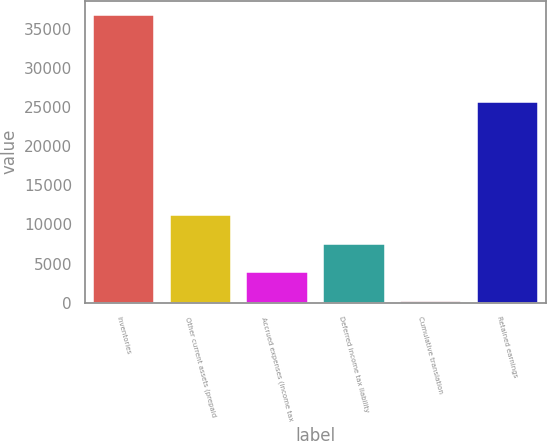Convert chart to OTSL. <chart><loc_0><loc_0><loc_500><loc_500><bar_chart><fcel>Inventories<fcel>Other current assets (prepaid<fcel>Accrued expenses (income tax<fcel>Deferred income tax liability<fcel>Cumulative translation<fcel>Retained earnings<nl><fcel>36699<fcel>11193.1<fcel>3905.7<fcel>7549.4<fcel>262<fcel>25623<nl></chart> 